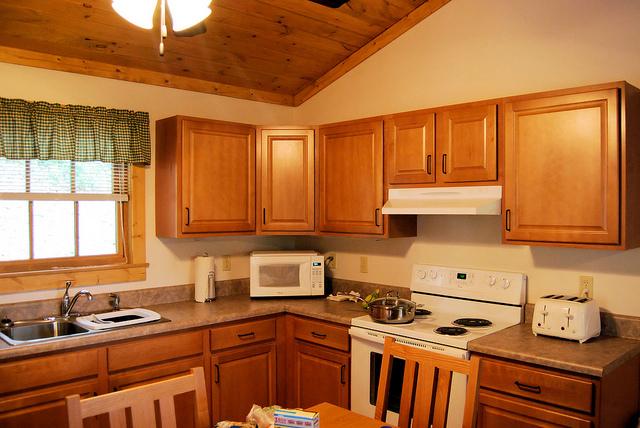What room is shown here?
Keep it brief. Kitchen. What color is the toaster?
Quick response, please. White. What type of lighting is used in this room?
Quick response, please. Overhead. 